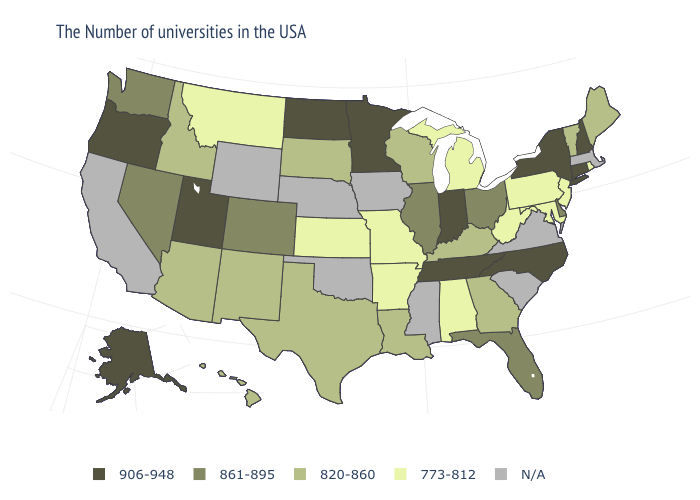What is the value of New Mexico?
Be succinct. 820-860. Among the states that border Mississippi , which have the highest value?
Give a very brief answer. Tennessee. Does the map have missing data?
Answer briefly. Yes. Name the states that have a value in the range 820-860?
Write a very short answer. Maine, Vermont, Georgia, Kentucky, Wisconsin, Louisiana, Texas, South Dakota, New Mexico, Arizona, Idaho, Hawaii. Name the states that have a value in the range 820-860?
Quick response, please. Maine, Vermont, Georgia, Kentucky, Wisconsin, Louisiana, Texas, South Dakota, New Mexico, Arizona, Idaho, Hawaii. What is the value of North Dakota?
Give a very brief answer. 906-948. Does Maine have the highest value in the USA?
Quick response, please. No. What is the value of New Jersey?
Concise answer only. 773-812. What is the value of New Jersey?
Quick response, please. 773-812. Does Georgia have the lowest value in the USA?
Give a very brief answer. No. What is the lowest value in the Northeast?
Be succinct. 773-812. Does the first symbol in the legend represent the smallest category?
Write a very short answer. No. 